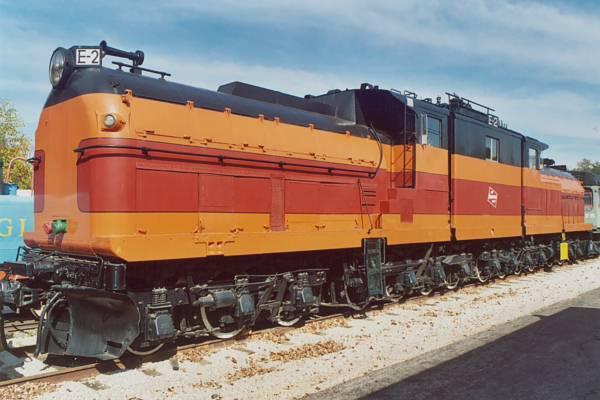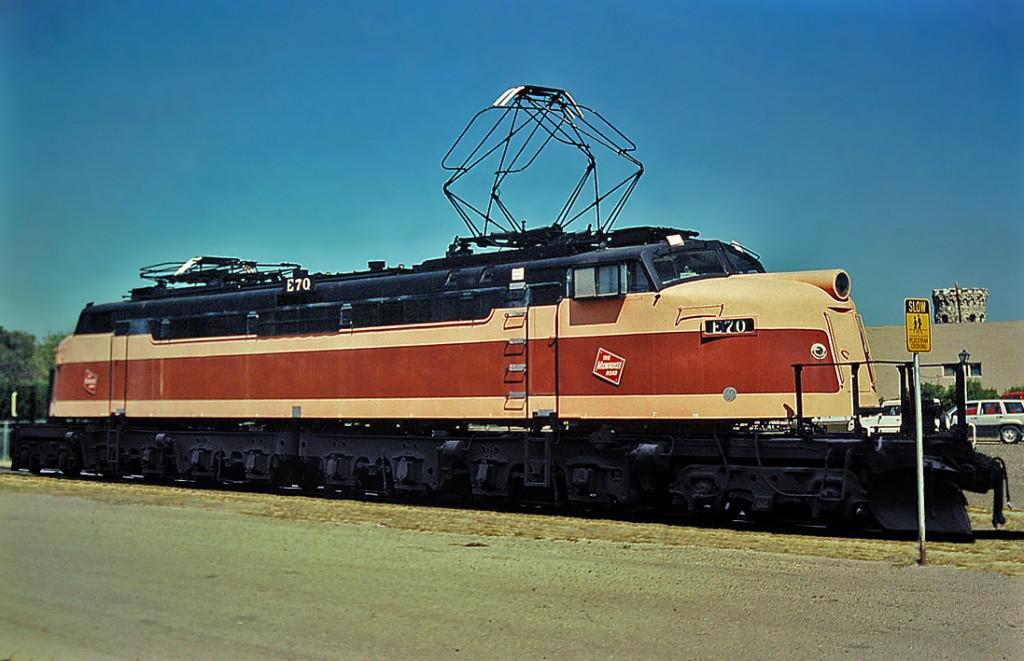The first image is the image on the left, the second image is the image on the right. Evaluate the accuracy of this statement regarding the images: "there are no power poles in the image on the right". Is it true? Answer yes or no. Yes. The first image is the image on the left, the second image is the image on the right. Considering the images on both sides, is "Two trains are angled in different directions." valid? Answer yes or no. Yes. 